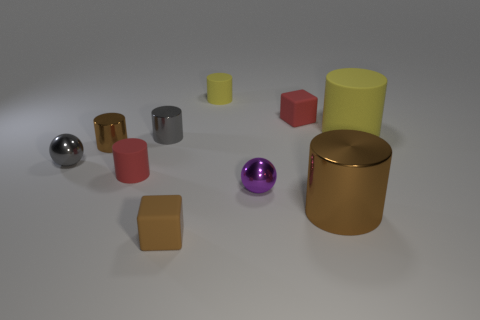Subtract all red cylinders. How many cylinders are left? 5 Subtract all yellow matte cylinders. How many cylinders are left? 4 Subtract all purple cylinders. Subtract all cyan cubes. How many cylinders are left? 6 Subtract all cubes. How many objects are left? 8 Add 5 big metal things. How many big metal things are left? 6 Add 2 gray metallic balls. How many gray metallic balls exist? 3 Subtract 0 purple blocks. How many objects are left? 10 Subtract all big cyan matte cylinders. Subtract all large brown things. How many objects are left? 9 